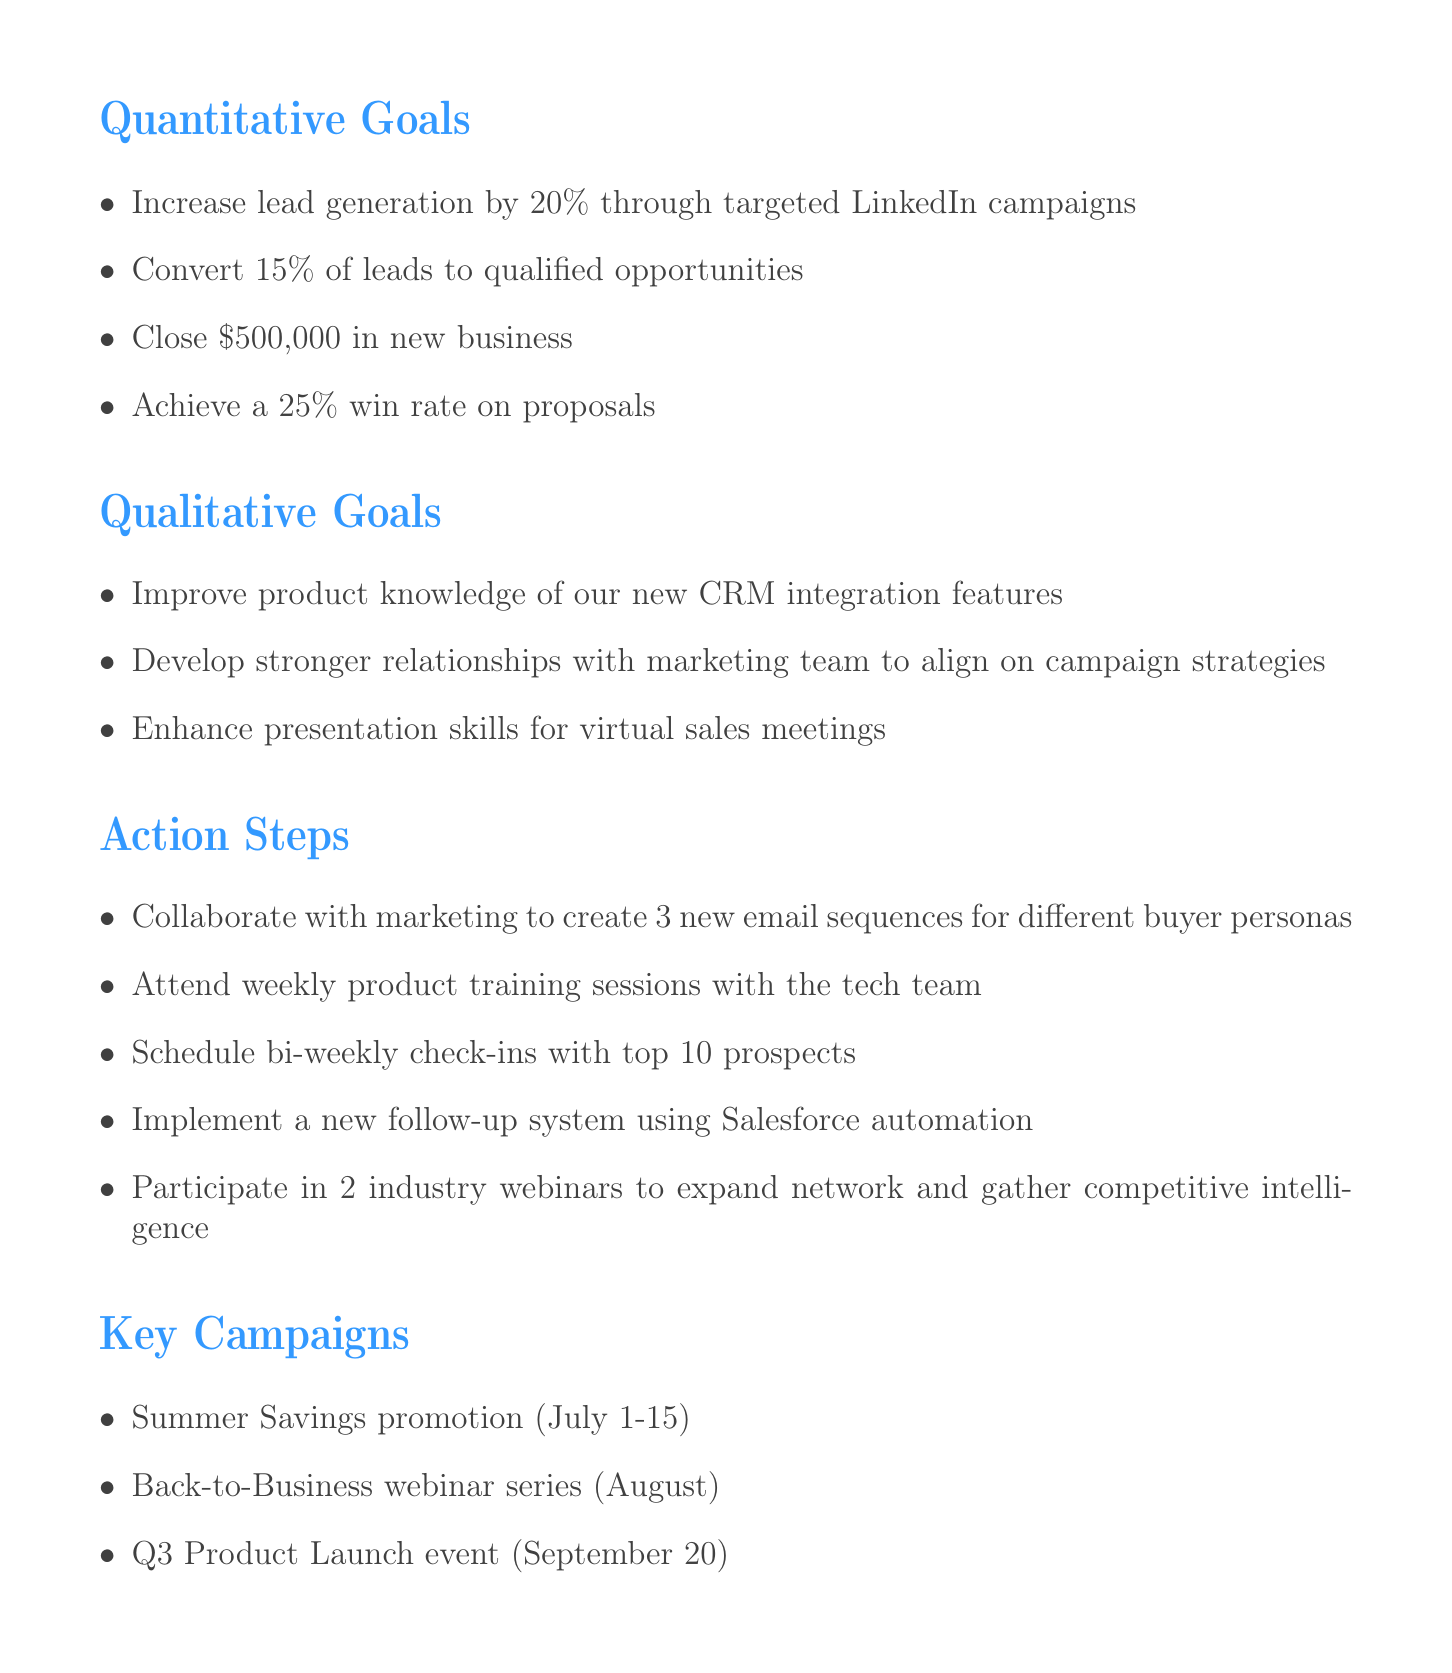What is the target percentage increase for lead generation? The document states the goal to increase lead generation by 20%.
Answer: 20% How much new business is aimed to be closed? The document specifies a goal of closing $500,000 in new business.
Answer: $500,000 What is the win rate target on proposals? The document indicates that the goal is to achieve a 25% win rate on proposals.
Answer: 25% How many new email sequences are planned to be created? The action steps mention collaborating with marketing to create 3 new email sequences for different buyer personas.
Answer: 3 Which month is the Q3 Product Launch event scheduled for? The document lists the Q3 Product Launch event date as September 20.
Answer: September How many industry webinars will be participated in? The action steps state participation in 2 industry webinars.
Answer: 2 What support is needed from the graphic design team? The document mentions needing support for custom proposal templates from the graphic design team.
Answer: custom proposal templates What qualitative goal focuses on improving relationships? The document indicates a qualitative goal to develop stronger relationships with the marketing team.
Answer: stronger relationships with marketing team 